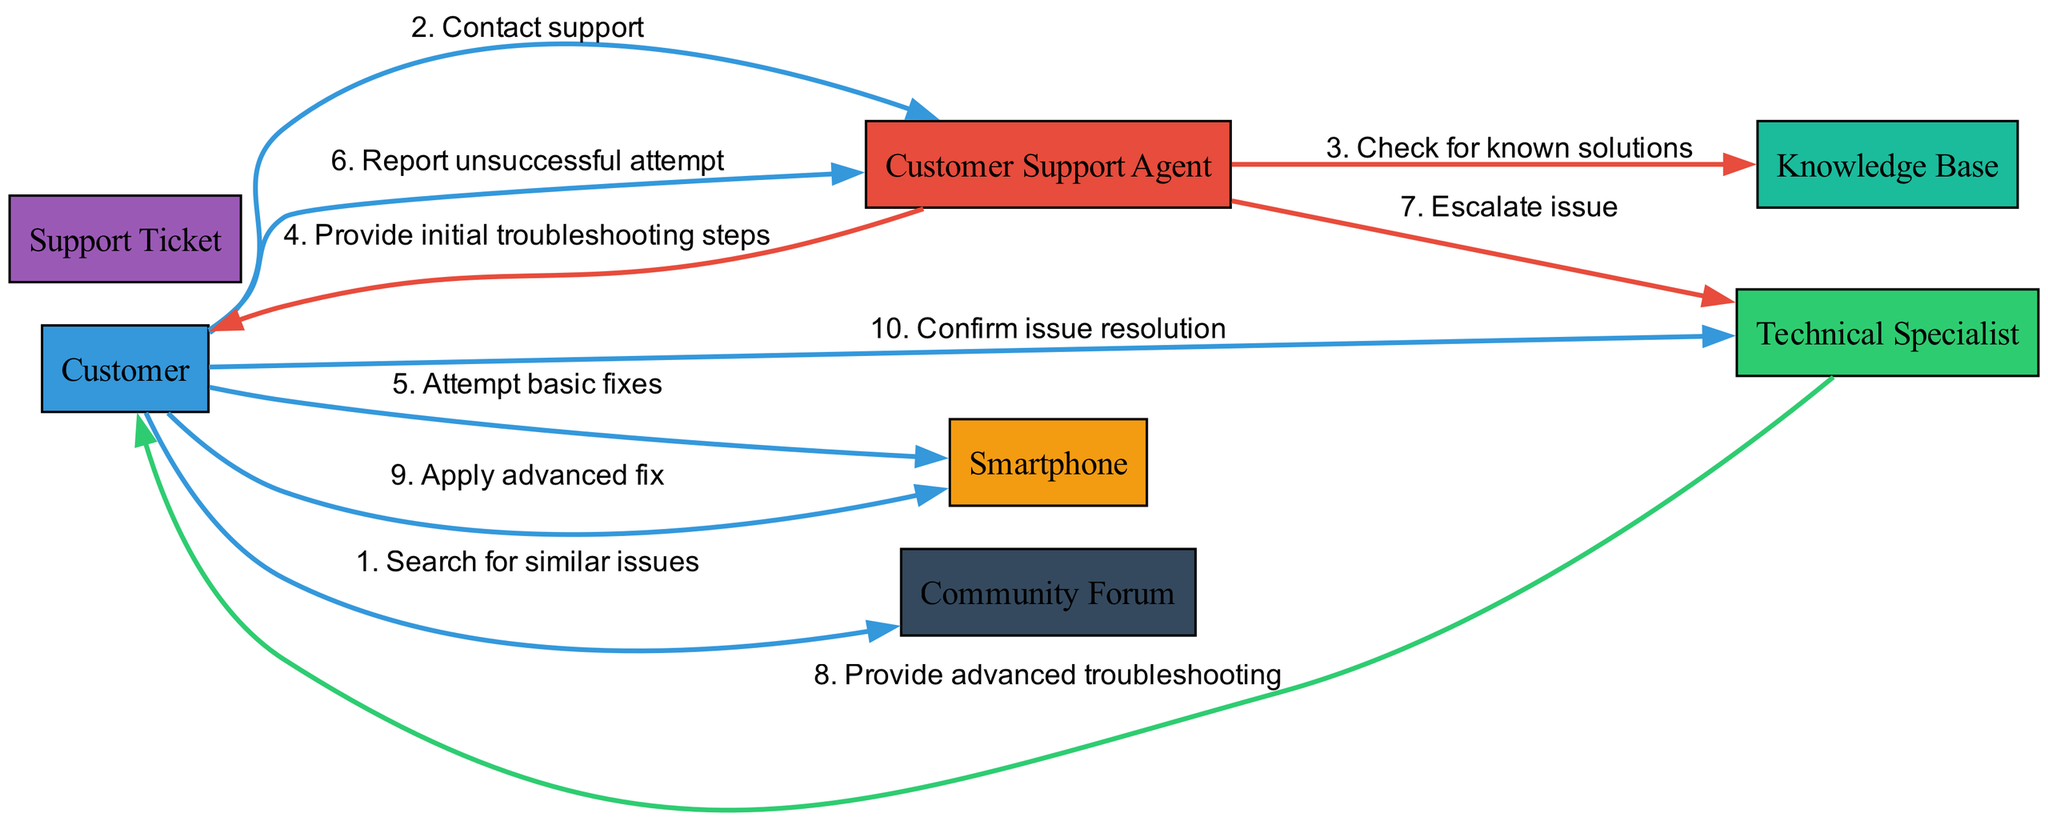What are the three main actors in the diagram? The diagram lists three actors: Customer, Customer Support Agent, and Technical Specialist. These are identified as the entities involved in the sequence of interactions.
Answer: Customer, Customer Support Agent, Technical Specialist How many total interactions are shown in the diagram? Counting the interactions listed in the sequence, there are ten distinct interactions between the actors and objects within the diagram.
Answer: 10 What action does the Customer take to troubleshoot before contacting support? The Customer first searches for similar issues in the Community Forum before reaching out to the Customer Support Agent for assistance.
Answer: Search for similar issues Which actor escalates the issue to the Technical Specialist? The Customer Support Agent is responsible for escalating the issue after initial troubleshooting has failed and further assistance is required.
Answer: Customer Support Agent What is the first message exchanged in the support process? The first message exchanged is when the Customer contacts the Customer Support Agent to initiate support for the technical issue.
Answer: Contact support After reporting an unsuccessful attempt, who does the Customer Support Agent communicate with next? After the Customer reports unsuccessful attempts to resolve the issue, the Customer Support Agent escalates the problem to the Technical Specialist for further assistance.
Answer: Technical Specialist What does the Technical Specialist provide to the Customer? The Technical Specialist provides advanced troubleshooting steps to the Customer to help resolve the technical issue with the smartphone.
Answer: Advanced troubleshooting What does the Customer do after receiving advanced troubleshooting from the Technical Specialist? Following the advanced troubleshooting guidance, the Customer applies the advanced fix to their smartphone to attempt to resolve the issue.
Answer: Apply advanced fix Which object does the Customer interact with while attempting basic fixes? The Customer directly interacts with the Smartphone when attempting to execute basic troubleshooting fixes to address the technical issue.
Answer: Smartphone What source does the Customer Support Agent utilize to find known solutions? The Customer Support Agent checks the Knowledge Base to look for any known solutions that might help resolve the Customer's issue with the smartphone.
Answer: Knowledge Base 